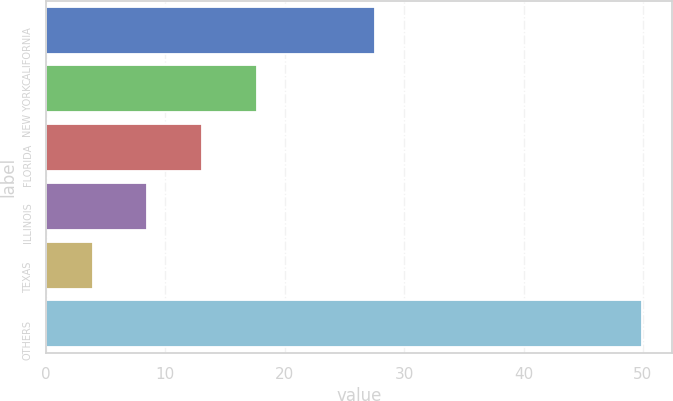<chart> <loc_0><loc_0><loc_500><loc_500><bar_chart><fcel>CALIFORNIA<fcel>NEW YORK<fcel>FLORIDA<fcel>ILLINOIS<fcel>TEXAS<fcel>OTHERS<nl><fcel>27.6<fcel>17.7<fcel>13.1<fcel>8.5<fcel>3.9<fcel>49.9<nl></chart> 